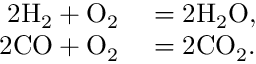Convert formula to latex. <formula><loc_0><loc_0><loc_500><loc_500>\begin{array} { r l } { 2 H _ { 2 } + O _ { 2 } } & = 2 H _ { 2 } O , } \\ { 2 C O + O _ { 2 } } & = 2 C O _ { 2 } . } \end{array}</formula> 